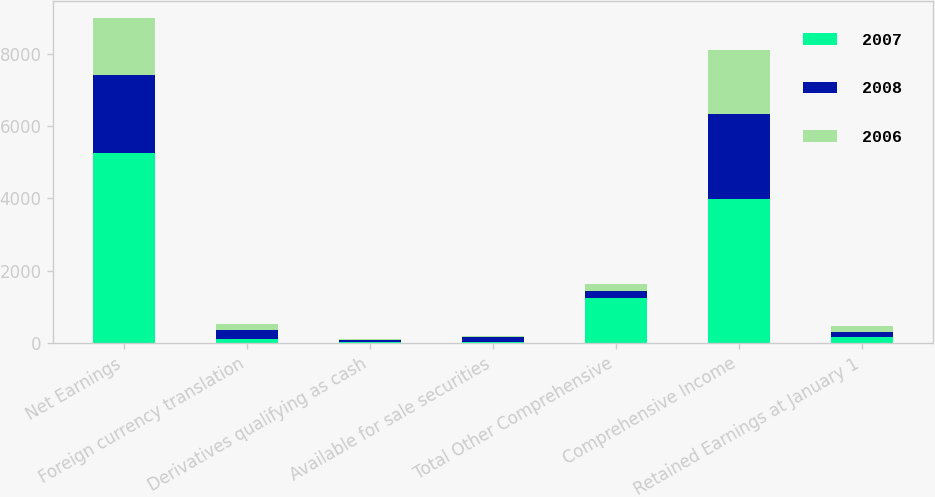Convert chart. <chart><loc_0><loc_0><loc_500><loc_500><stacked_bar_chart><ecel><fcel>Net Earnings<fcel>Foreign currency translation<fcel>Derivatives qualifying as cash<fcel>Available for sale securities<fcel>Total Other Comprehensive<fcel>Comprehensive Income<fcel>Retained Earnings at January 1<nl><fcel>2007<fcel>5247<fcel>123<fcel>42<fcel>37<fcel>1258<fcel>3989<fcel>159<nl><fcel>2008<fcel>2165<fcel>240<fcel>42<fcel>139<fcel>184<fcel>2349<fcel>159<nl><fcel>2006<fcel>1585<fcel>159<fcel>34<fcel>12<fcel>184<fcel>1769<fcel>159<nl></chart> 